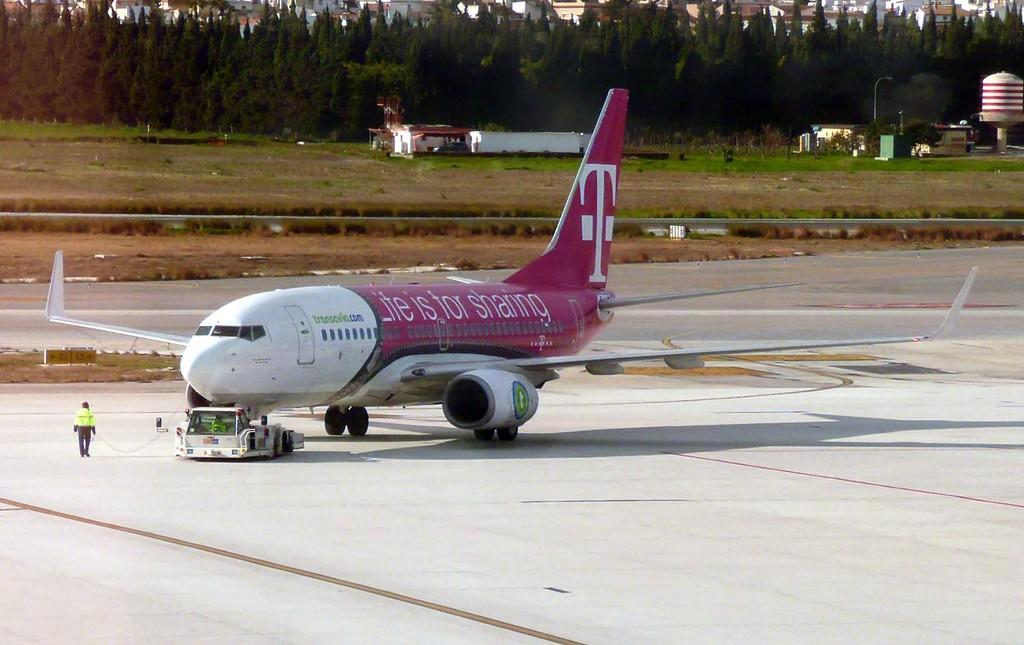<image>
Relay a brief, clear account of the picture shown. A pink and white airplane carries the phrase "Life is for sharing" on its fuselage. 